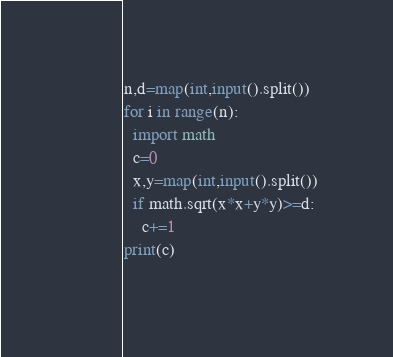<code> <loc_0><loc_0><loc_500><loc_500><_Python_>n,d=map(int,input().split())
for i in range(n):
  import math
  c=0
  x,y=map(int,input().split())
  if math.sqrt(x*x+y*y)>=d:
    c+=1
print(c)
    </code> 